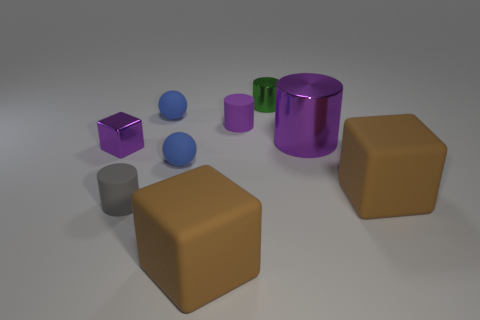How many brown blocks must be subtracted to get 1 brown blocks? 1 Subtract all matte blocks. How many blocks are left? 1 Subtract all tiny gray rubber cylinders. Subtract all tiny purple rubber cylinders. How many objects are left? 7 Add 6 green shiny cylinders. How many green shiny cylinders are left? 7 Add 1 small purple objects. How many small purple objects exist? 3 Subtract all brown blocks. How many blocks are left? 1 Subtract 0 gray cubes. How many objects are left? 9 Subtract all blocks. How many objects are left? 6 Subtract 4 cylinders. How many cylinders are left? 0 Subtract all red balls. Subtract all cyan blocks. How many balls are left? 2 